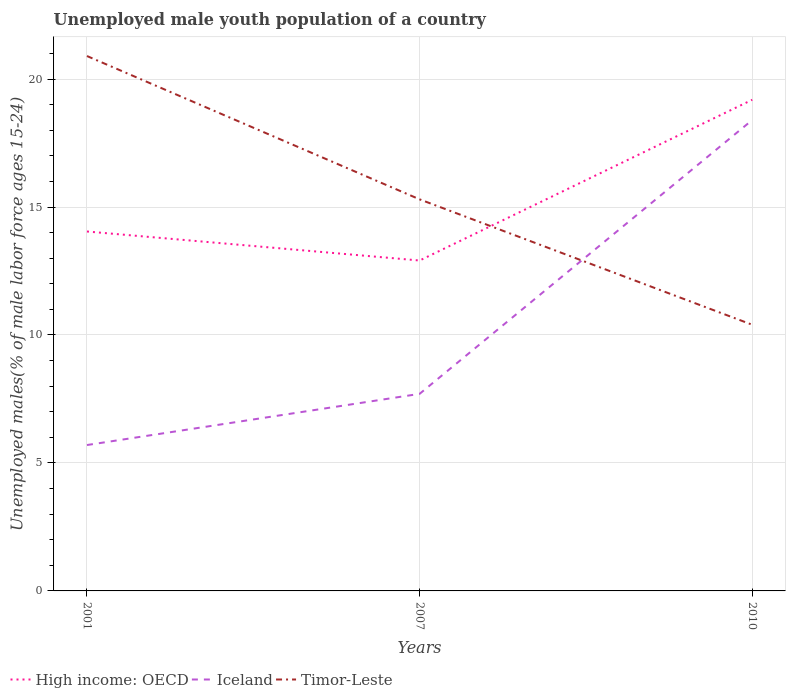Is the number of lines equal to the number of legend labels?
Ensure brevity in your answer.  Yes. Across all years, what is the maximum percentage of unemployed male youth population in Iceland?
Ensure brevity in your answer.  5.7. In which year was the percentage of unemployed male youth population in Timor-Leste maximum?
Your answer should be compact. 2010. What is the total percentage of unemployed male youth population in Timor-Leste in the graph?
Offer a terse response. 4.9. What is the difference between the highest and the second highest percentage of unemployed male youth population in High income: OECD?
Ensure brevity in your answer.  6.28. What is the difference between the highest and the lowest percentage of unemployed male youth population in Iceland?
Give a very brief answer. 1. Is the percentage of unemployed male youth population in High income: OECD strictly greater than the percentage of unemployed male youth population in Iceland over the years?
Give a very brief answer. No. How many lines are there?
Provide a succinct answer. 3. How many years are there in the graph?
Make the answer very short. 3. Does the graph contain grids?
Your answer should be very brief. Yes. What is the title of the graph?
Ensure brevity in your answer.  Unemployed male youth population of a country. Does "Antigua and Barbuda" appear as one of the legend labels in the graph?
Offer a very short reply. No. What is the label or title of the X-axis?
Offer a terse response. Years. What is the label or title of the Y-axis?
Make the answer very short. Unemployed males(% of male labor force ages 15-24). What is the Unemployed males(% of male labor force ages 15-24) of High income: OECD in 2001?
Make the answer very short. 14.04. What is the Unemployed males(% of male labor force ages 15-24) in Iceland in 2001?
Your answer should be very brief. 5.7. What is the Unemployed males(% of male labor force ages 15-24) in Timor-Leste in 2001?
Give a very brief answer. 20.9. What is the Unemployed males(% of male labor force ages 15-24) of High income: OECD in 2007?
Make the answer very short. 12.91. What is the Unemployed males(% of male labor force ages 15-24) of Iceland in 2007?
Offer a terse response. 7.7. What is the Unemployed males(% of male labor force ages 15-24) of Timor-Leste in 2007?
Provide a succinct answer. 15.3. What is the Unemployed males(% of male labor force ages 15-24) of High income: OECD in 2010?
Provide a succinct answer. 19.19. What is the Unemployed males(% of male labor force ages 15-24) in Iceland in 2010?
Provide a short and direct response. 18.4. What is the Unemployed males(% of male labor force ages 15-24) in Timor-Leste in 2010?
Keep it short and to the point. 10.4. Across all years, what is the maximum Unemployed males(% of male labor force ages 15-24) of High income: OECD?
Your response must be concise. 19.19. Across all years, what is the maximum Unemployed males(% of male labor force ages 15-24) of Iceland?
Your answer should be compact. 18.4. Across all years, what is the maximum Unemployed males(% of male labor force ages 15-24) of Timor-Leste?
Your answer should be very brief. 20.9. Across all years, what is the minimum Unemployed males(% of male labor force ages 15-24) of High income: OECD?
Keep it short and to the point. 12.91. Across all years, what is the minimum Unemployed males(% of male labor force ages 15-24) of Iceland?
Provide a succinct answer. 5.7. Across all years, what is the minimum Unemployed males(% of male labor force ages 15-24) of Timor-Leste?
Provide a short and direct response. 10.4. What is the total Unemployed males(% of male labor force ages 15-24) in High income: OECD in the graph?
Give a very brief answer. 46.15. What is the total Unemployed males(% of male labor force ages 15-24) in Iceland in the graph?
Your answer should be compact. 31.8. What is the total Unemployed males(% of male labor force ages 15-24) of Timor-Leste in the graph?
Give a very brief answer. 46.6. What is the difference between the Unemployed males(% of male labor force ages 15-24) in High income: OECD in 2001 and that in 2007?
Offer a terse response. 1.13. What is the difference between the Unemployed males(% of male labor force ages 15-24) of High income: OECD in 2001 and that in 2010?
Provide a short and direct response. -5.15. What is the difference between the Unemployed males(% of male labor force ages 15-24) in Timor-Leste in 2001 and that in 2010?
Provide a succinct answer. 10.5. What is the difference between the Unemployed males(% of male labor force ages 15-24) in High income: OECD in 2007 and that in 2010?
Make the answer very short. -6.28. What is the difference between the Unemployed males(% of male labor force ages 15-24) of Iceland in 2007 and that in 2010?
Keep it short and to the point. -10.7. What is the difference between the Unemployed males(% of male labor force ages 15-24) in Timor-Leste in 2007 and that in 2010?
Your answer should be very brief. 4.9. What is the difference between the Unemployed males(% of male labor force ages 15-24) of High income: OECD in 2001 and the Unemployed males(% of male labor force ages 15-24) of Iceland in 2007?
Make the answer very short. 6.34. What is the difference between the Unemployed males(% of male labor force ages 15-24) in High income: OECD in 2001 and the Unemployed males(% of male labor force ages 15-24) in Timor-Leste in 2007?
Provide a short and direct response. -1.26. What is the difference between the Unemployed males(% of male labor force ages 15-24) in Iceland in 2001 and the Unemployed males(% of male labor force ages 15-24) in Timor-Leste in 2007?
Offer a terse response. -9.6. What is the difference between the Unemployed males(% of male labor force ages 15-24) of High income: OECD in 2001 and the Unemployed males(% of male labor force ages 15-24) of Iceland in 2010?
Provide a succinct answer. -4.36. What is the difference between the Unemployed males(% of male labor force ages 15-24) of High income: OECD in 2001 and the Unemployed males(% of male labor force ages 15-24) of Timor-Leste in 2010?
Your response must be concise. 3.64. What is the difference between the Unemployed males(% of male labor force ages 15-24) of High income: OECD in 2007 and the Unemployed males(% of male labor force ages 15-24) of Iceland in 2010?
Give a very brief answer. -5.49. What is the difference between the Unemployed males(% of male labor force ages 15-24) in High income: OECD in 2007 and the Unemployed males(% of male labor force ages 15-24) in Timor-Leste in 2010?
Make the answer very short. 2.51. What is the difference between the Unemployed males(% of male labor force ages 15-24) of Iceland in 2007 and the Unemployed males(% of male labor force ages 15-24) of Timor-Leste in 2010?
Provide a short and direct response. -2.7. What is the average Unemployed males(% of male labor force ages 15-24) in High income: OECD per year?
Give a very brief answer. 15.38. What is the average Unemployed males(% of male labor force ages 15-24) in Iceland per year?
Keep it short and to the point. 10.6. What is the average Unemployed males(% of male labor force ages 15-24) of Timor-Leste per year?
Give a very brief answer. 15.53. In the year 2001, what is the difference between the Unemployed males(% of male labor force ages 15-24) of High income: OECD and Unemployed males(% of male labor force ages 15-24) of Iceland?
Your answer should be very brief. 8.34. In the year 2001, what is the difference between the Unemployed males(% of male labor force ages 15-24) in High income: OECD and Unemployed males(% of male labor force ages 15-24) in Timor-Leste?
Offer a very short reply. -6.86. In the year 2001, what is the difference between the Unemployed males(% of male labor force ages 15-24) in Iceland and Unemployed males(% of male labor force ages 15-24) in Timor-Leste?
Your response must be concise. -15.2. In the year 2007, what is the difference between the Unemployed males(% of male labor force ages 15-24) of High income: OECD and Unemployed males(% of male labor force ages 15-24) of Iceland?
Offer a very short reply. 5.21. In the year 2007, what is the difference between the Unemployed males(% of male labor force ages 15-24) in High income: OECD and Unemployed males(% of male labor force ages 15-24) in Timor-Leste?
Your answer should be compact. -2.39. In the year 2007, what is the difference between the Unemployed males(% of male labor force ages 15-24) of Iceland and Unemployed males(% of male labor force ages 15-24) of Timor-Leste?
Provide a short and direct response. -7.6. In the year 2010, what is the difference between the Unemployed males(% of male labor force ages 15-24) in High income: OECD and Unemployed males(% of male labor force ages 15-24) in Iceland?
Give a very brief answer. 0.79. In the year 2010, what is the difference between the Unemployed males(% of male labor force ages 15-24) in High income: OECD and Unemployed males(% of male labor force ages 15-24) in Timor-Leste?
Your response must be concise. 8.79. In the year 2010, what is the difference between the Unemployed males(% of male labor force ages 15-24) in Iceland and Unemployed males(% of male labor force ages 15-24) in Timor-Leste?
Your answer should be compact. 8. What is the ratio of the Unemployed males(% of male labor force ages 15-24) in High income: OECD in 2001 to that in 2007?
Provide a short and direct response. 1.09. What is the ratio of the Unemployed males(% of male labor force ages 15-24) of Iceland in 2001 to that in 2007?
Your answer should be compact. 0.74. What is the ratio of the Unemployed males(% of male labor force ages 15-24) in Timor-Leste in 2001 to that in 2007?
Offer a very short reply. 1.37. What is the ratio of the Unemployed males(% of male labor force ages 15-24) of High income: OECD in 2001 to that in 2010?
Keep it short and to the point. 0.73. What is the ratio of the Unemployed males(% of male labor force ages 15-24) in Iceland in 2001 to that in 2010?
Your answer should be compact. 0.31. What is the ratio of the Unemployed males(% of male labor force ages 15-24) of Timor-Leste in 2001 to that in 2010?
Your response must be concise. 2.01. What is the ratio of the Unemployed males(% of male labor force ages 15-24) in High income: OECD in 2007 to that in 2010?
Ensure brevity in your answer.  0.67. What is the ratio of the Unemployed males(% of male labor force ages 15-24) in Iceland in 2007 to that in 2010?
Ensure brevity in your answer.  0.42. What is the ratio of the Unemployed males(% of male labor force ages 15-24) in Timor-Leste in 2007 to that in 2010?
Ensure brevity in your answer.  1.47. What is the difference between the highest and the second highest Unemployed males(% of male labor force ages 15-24) of High income: OECD?
Offer a terse response. 5.15. What is the difference between the highest and the second highest Unemployed males(% of male labor force ages 15-24) in Iceland?
Make the answer very short. 10.7. What is the difference between the highest and the lowest Unemployed males(% of male labor force ages 15-24) in High income: OECD?
Provide a short and direct response. 6.28. What is the difference between the highest and the lowest Unemployed males(% of male labor force ages 15-24) of Iceland?
Your response must be concise. 12.7. 